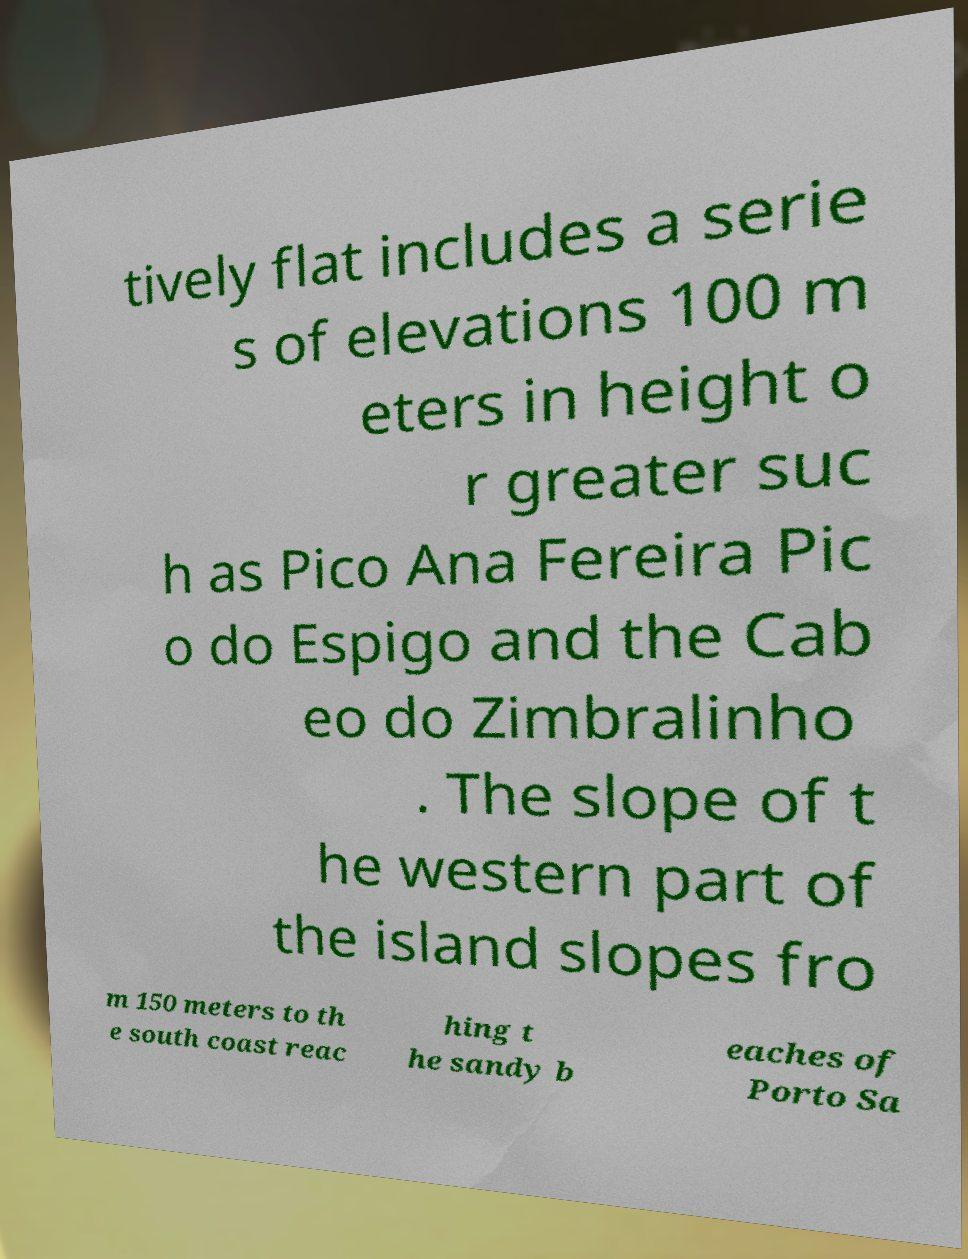Could you extract and type out the text from this image? tively flat includes a serie s of elevations 100 m eters in height o r greater suc h as Pico Ana Fereira Pic o do Espigo and the Cab eo do Zimbralinho . The slope of t he western part of the island slopes fro m 150 meters to th e south coast reac hing t he sandy b eaches of Porto Sa 